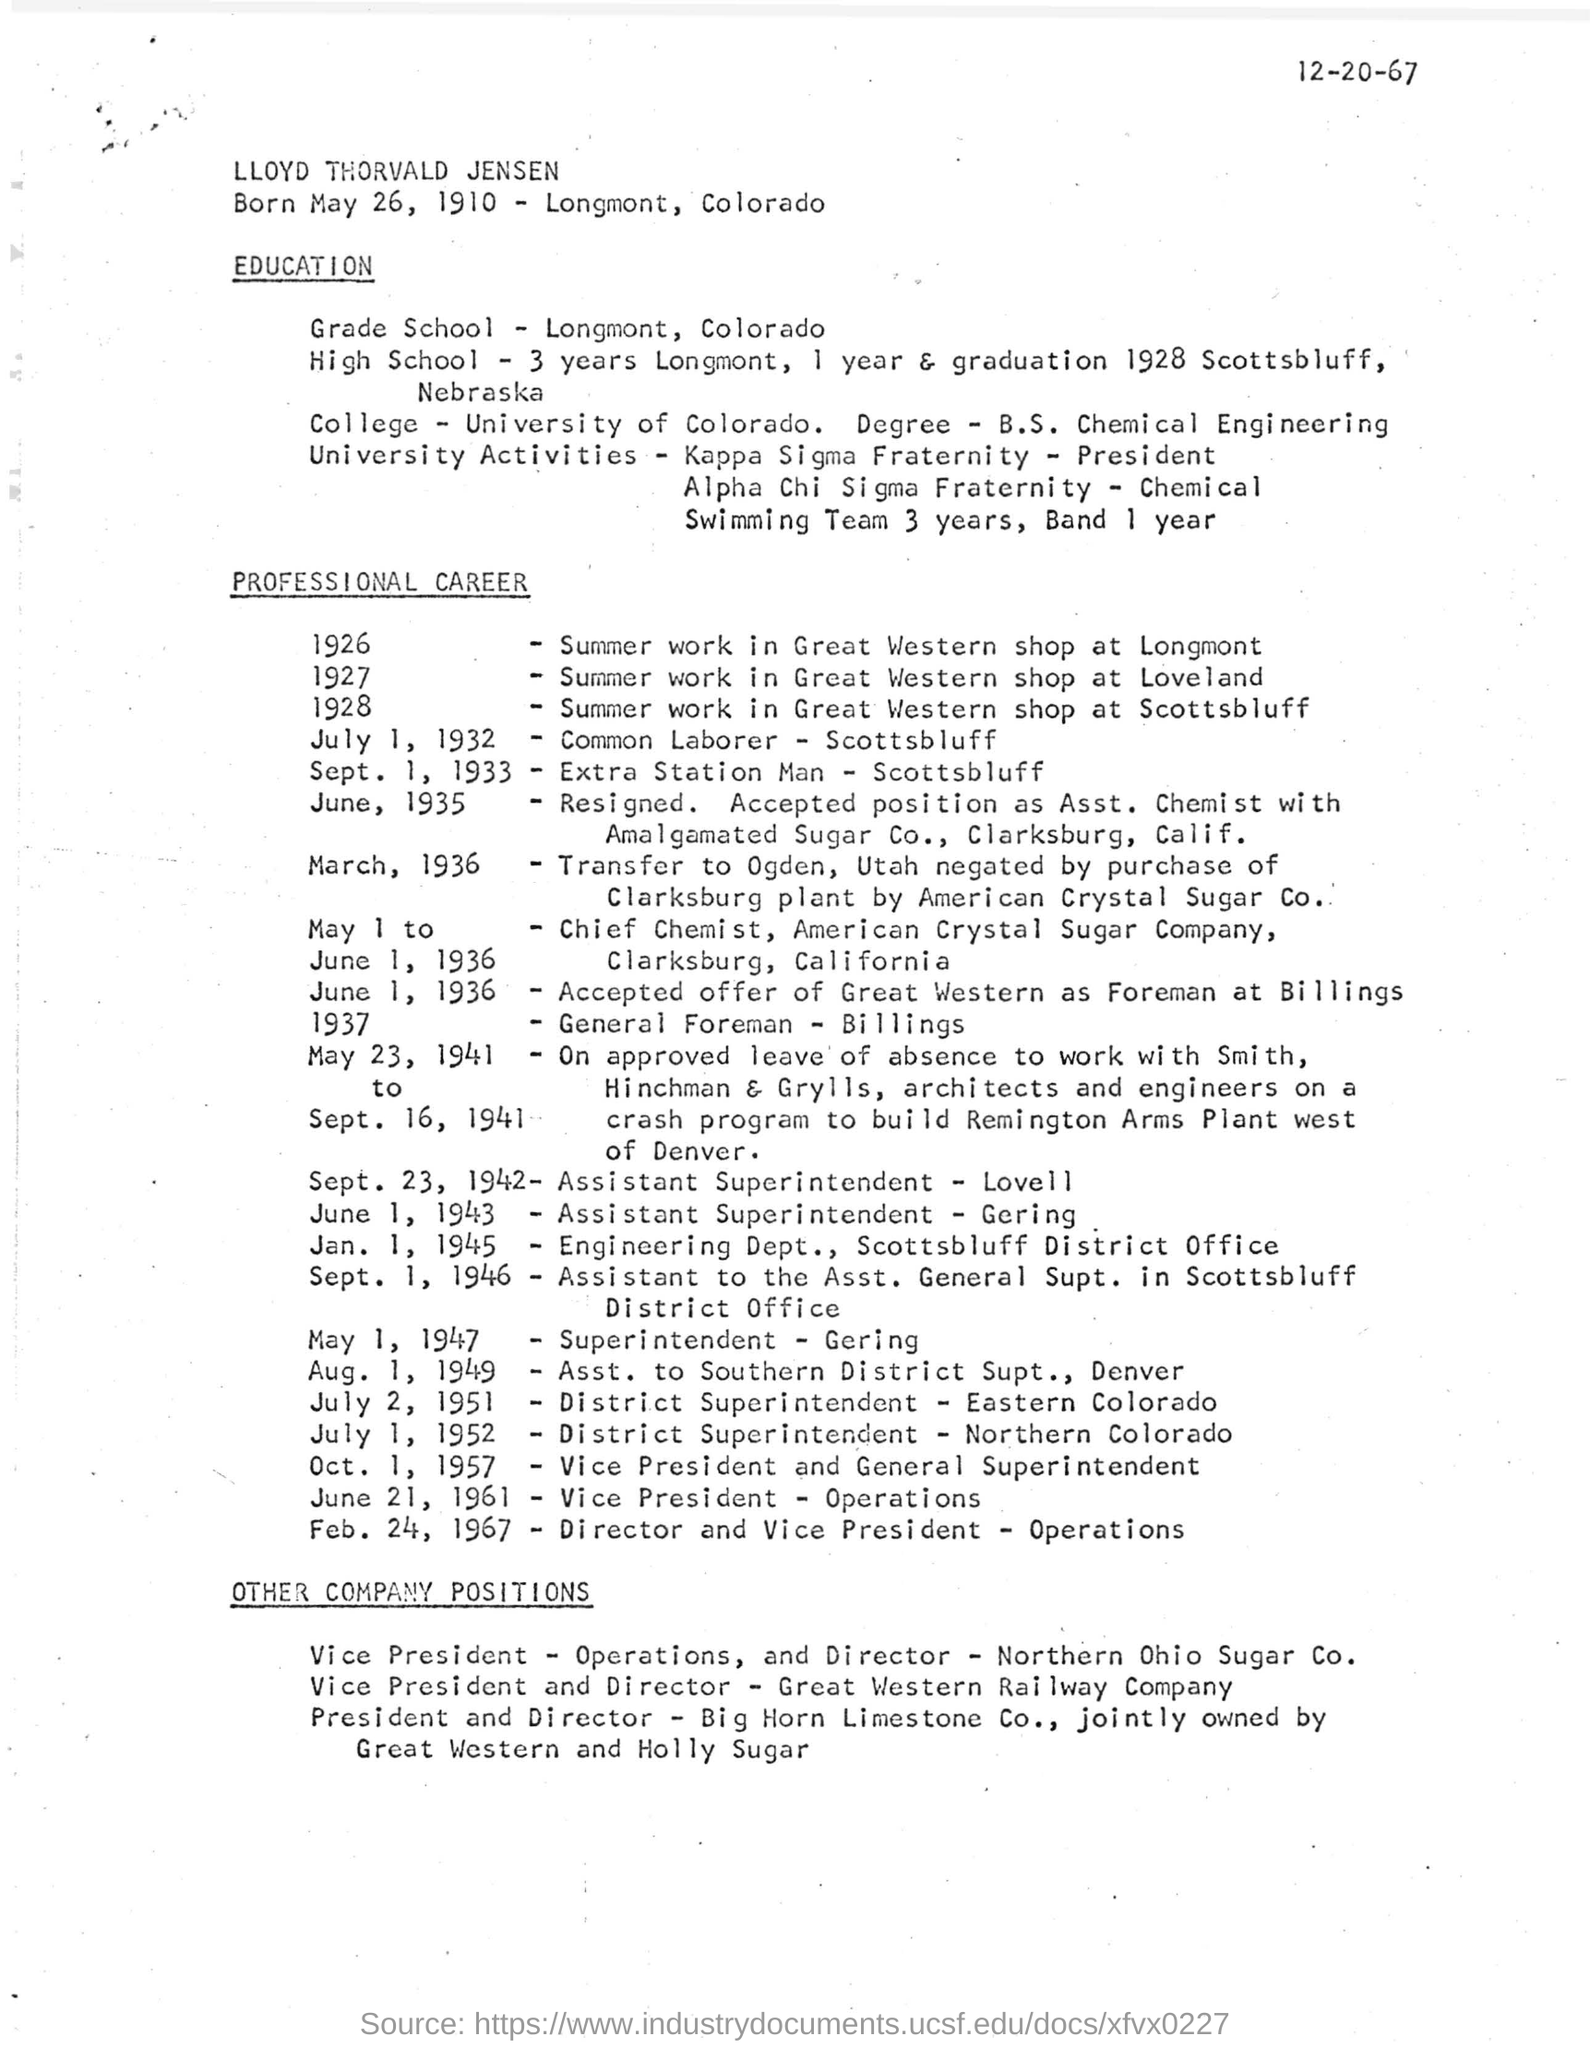What is the date of birth of Lloyd Thorvald Jensen?
Provide a succinct answer. May 26, 1910. 